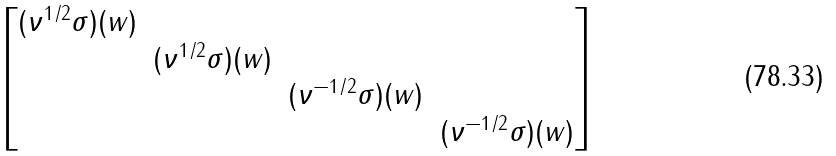Convert formula to latex. <formula><loc_0><loc_0><loc_500><loc_500>\begin{bmatrix} ( \nu ^ { 1 / 2 } \sigma ) ( w ) \\ & ( \nu ^ { 1 / 2 } \sigma ) ( w ) \\ & & ( \nu ^ { - 1 / 2 } \sigma ) ( w ) \\ & & & ( \nu ^ { - 1 / 2 } \sigma ) ( w ) \end{bmatrix}</formula> 